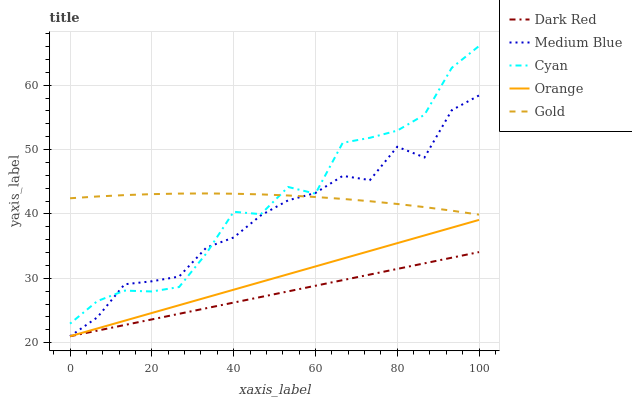Does Dark Red have the minimum area under the curve?
Answer yes or no. Yes. Does Gold have the maximum area under the curve?
Answer yes or no. Yes. Does Medium Blue have the minimum area under the curve?
Answer yes or no. No. Does Medium Blue have the maximum area under the curve?
Answer yes or no. No. Is Orange the smoothest?
Answer yes or no. Yes. Is Cyan the roughest?
Answer yes or no. Yes. Is Dark Red the smoothest?
Answer yes or no. No. Is Dark Red the roughest?
Answer yes or no. No. Does Orange have the lowest value?
Answer yes or no. Yes. Does Gold have the lowest value?
Answer yes or no. No. Does Cyan have the highest value?
Answer yes or no. Yes. Does Medium Blue have the highest value?
Answer yes or no. No. Is Orange less than Gold?
Answer yes or no. Yes. Is Gold greater than Dark Red?
Answer yes or no. Yes. Does Orange intersect Dark Red?
Answer yes or no. Yes. Is Orange less than Dark Red?
Answer yes or no. No. Is Orange greater than Dark Red?
Answer yes or no. No. Does Orange intersect Gold?
Answer yes or no. No. 